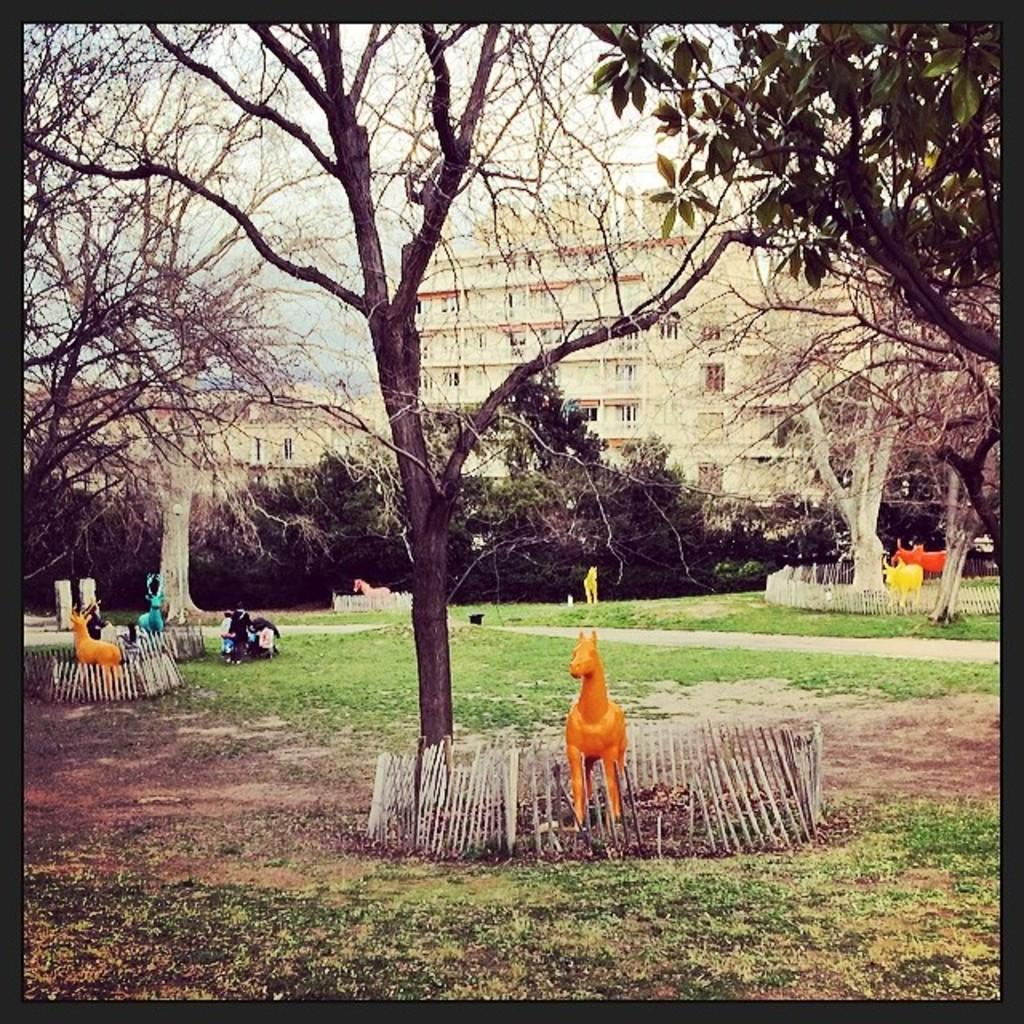What type of structures can be seen in the image? There are buildings in the image. What natural elements are present in the image? There are trees and grass in the image. What type of objects can be seen in the image? There are toys of animals and small fences in the image. What architectural features are visible in the image? There are stone pillars in the image. Are there any living beings in the image? Yes, there are people in the image. What part of the natural environment is visible in the image? The sky is visible in the image. How many rabbits can be seen hopping on the people's toes in the image? There are no rabbits or toes visible in the image. What type of treatment is being administered to the stone pillars in the image? There is no treatment being administered to the stone pillars in the image; they are stationary architectural features. 